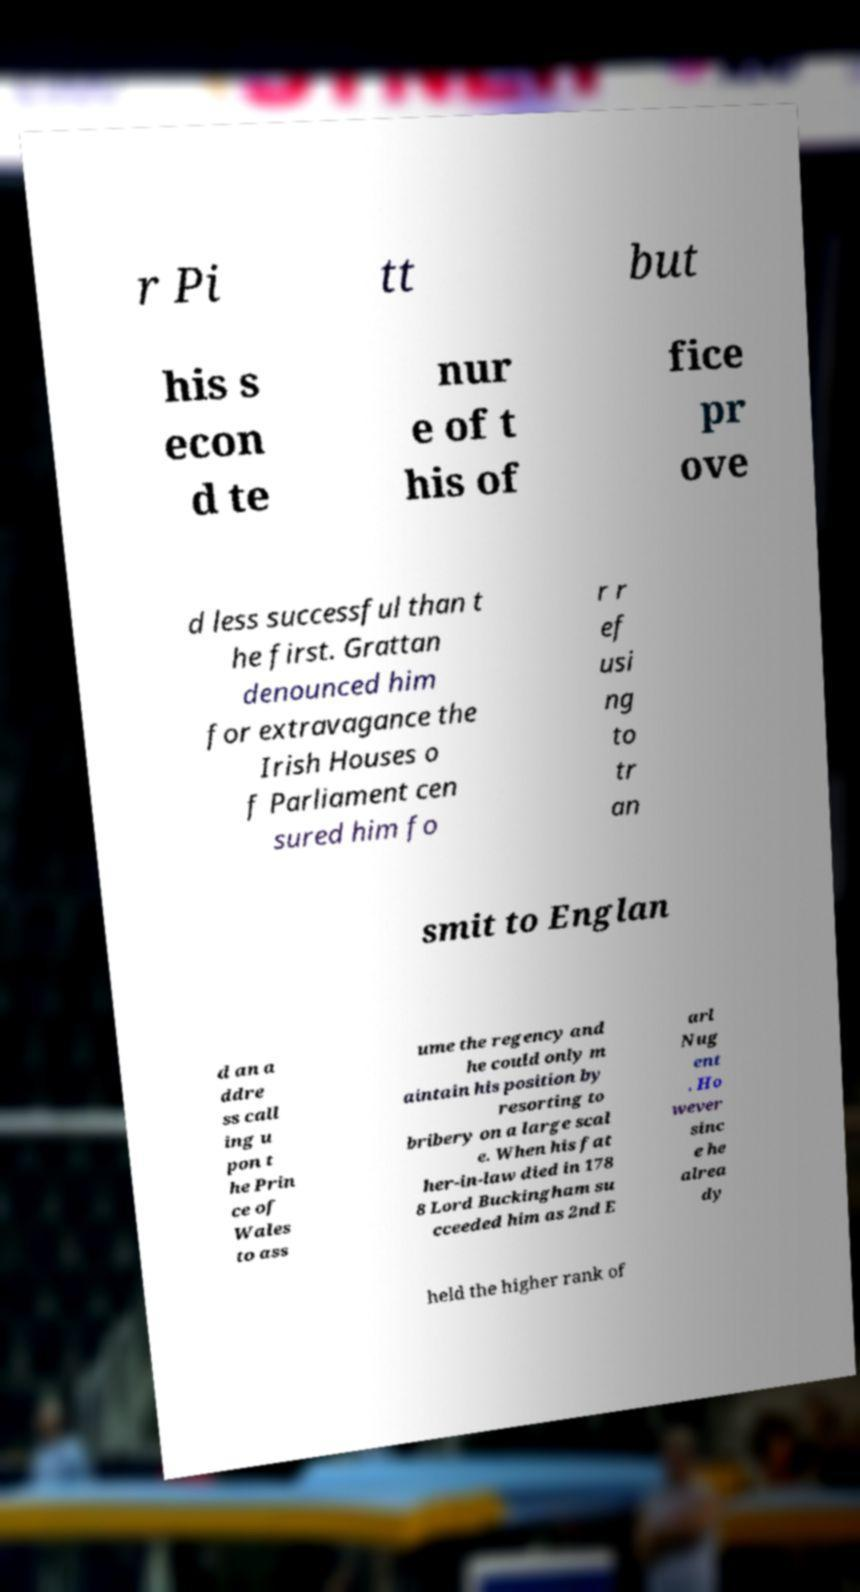Please read and relay the text visible in this image. What does it say? r Pi tt but his s econ d te nur e of t his of fice pr ove d less successful than t he first. Grattan denounced him for extravagance the Irish Houses o f Parliament cen sured him fo r r ef usi ng to tr an smit to Englan d an a ddre ss call ing u pon t he Prin ce of Wales to ass ume the regency and he could only m aintain his position by resorting to bribery on a large scal e. When his fat her-in-law died in 178 8 Lord Buckingham su cceeded him as 2nd E arl Nug ent . Ho wever sinc e he alrea dy held the higher rank of 